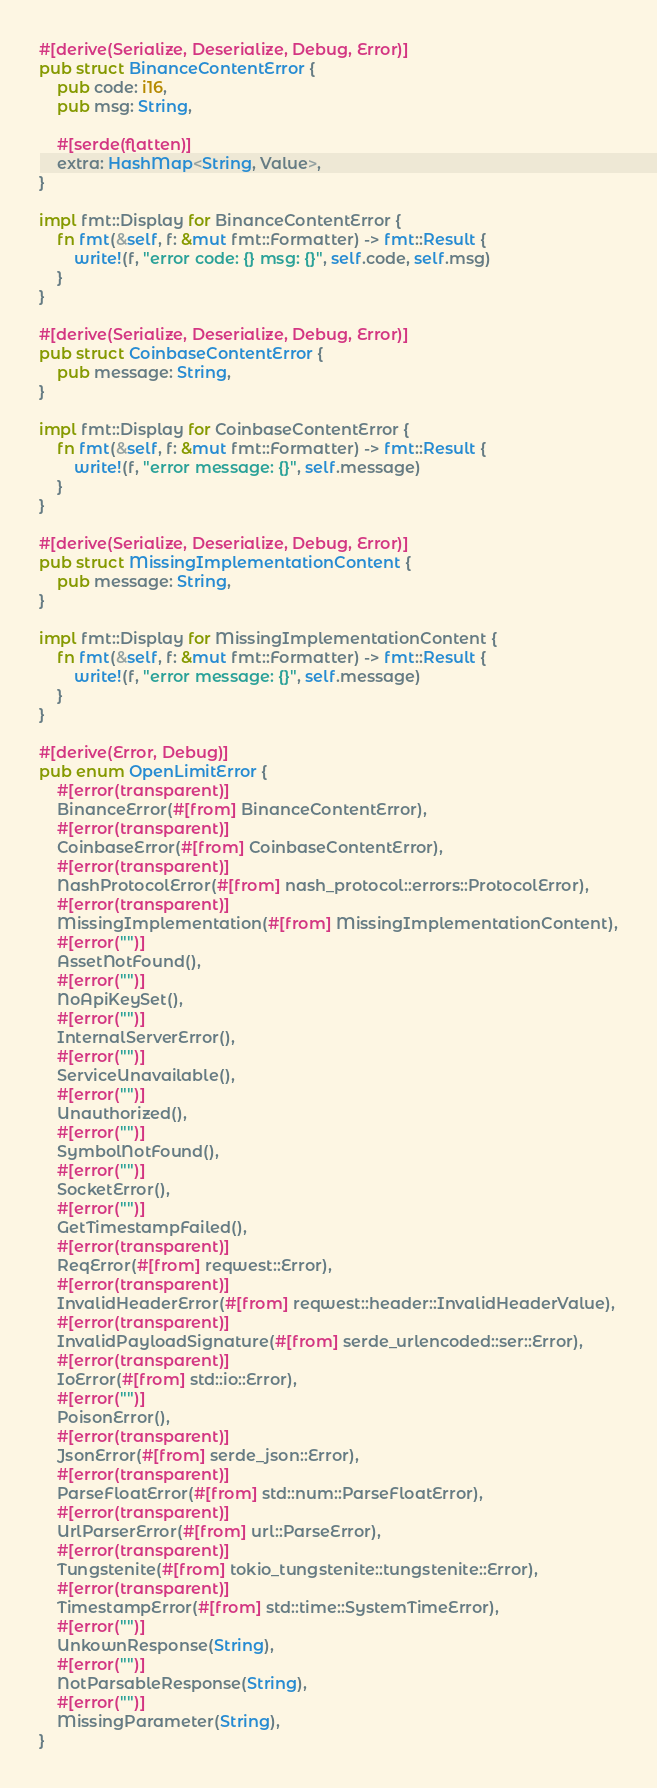Convert code to text. <code><loc_0><loc_0><loc_500><loc_500><_Rust_>
#[derive(Serialize, Deserialize, Debug, Error)]
pub struct BinanceContentError {
    pub code: i16,
    pub msg: String,

    #[serde(flatten)]
    extra: HashMap<String, Value>,
}

impl fmt::Display for BinanceContentError {
    fn fmt(&self, f: &mut fmt::Formatter) -> fmt::Result {
        write!(f, "error code: {} msg: {}", self.code, self.msg)
    }
}

#[derive(Serialize, Deserialize, Debug, Error)]
pub struct CoinbaseContentError {
    pub message: String,
}

impl fmt::Display for CoinbaseContentError {
    fn fmt(&self, f: &mut fmt::Formatter) -> fmt::Result {
        write!(f, "error message: {}", self.message)
    }
}

#[derive(Serialize, Deserialize, Debug, Error)]
pub struct MissingImplementationContent {
    pub message: String,
}

impl fmt::Display for MissingImplementationContent {
    fn fmt(&self, f: &mut fmt::Formatter) -> fmt::Result {
        write!(f, "error message: {}", self.message)
    }
}

#[derive(Error, Debug)]
pub enum OpenLimitError {
    #[error(transparent)]
    BinanceError(#[from] BinanceContentError),
    #[error(transparent)]
    CoinbaseError(#[from] CoinbaseContentError),
    #[error(transparent)]
    NashProtocolError(#[from] nash_protocol::errors::ProtocolError),
    #[error(transparent)]
    MissingImplementation(#[from] MissingImplementationContent),
    #[error("")]
    AssetNotFound(),
    #[error("")]
    NoApiKeySet(),
    #[error("")]
    InternalServerError(),
    #[error("")]
    ServiceUnavailable(),
    #[error("")]
    Unauthorized(),
    #[error("")]
    SymbolNotFound(),
    #[error("")]
    SocketError(),
    #[error("")]
    GetTimestampFailed(),
    #[error(transparent)]
    ReqError(#[from] reqwest::Error),
    #[error(transparent)]
    InvalidHeaderError(#[from] reqwest::header::InvalidHeaderValue),
    #[error(transparent)]
    InvalidPayloadSignature(#[from] serde_urlencoded::ser::Error),
    #[error(transparent)]
    IoError(#[from] std::io::Error),
    #[error("")]
    PoisonError(),
    #[error(transparent)]
    JsonError(#[from] serde_json::Error),
    #[error(transparent)]
    ParseFloatError(#[from] std::num::ParseFloatError),
    #[error(transparent)]
    UrlParserError(#[from] url::ParseError),
    #[error(transparent)]
    Tungstenite(#[from] tokio_tungstenite::tungstenite::Error),
    #[error(transparent)]
    TimestampError(#[from] std::time::SystemTimeError),
    #[error("")]
    UnkownResponse(String),
    #[error("")]
    NotParsableResponse(String),
    #[error("")]
    MissingParameter(String),
}
</code> 